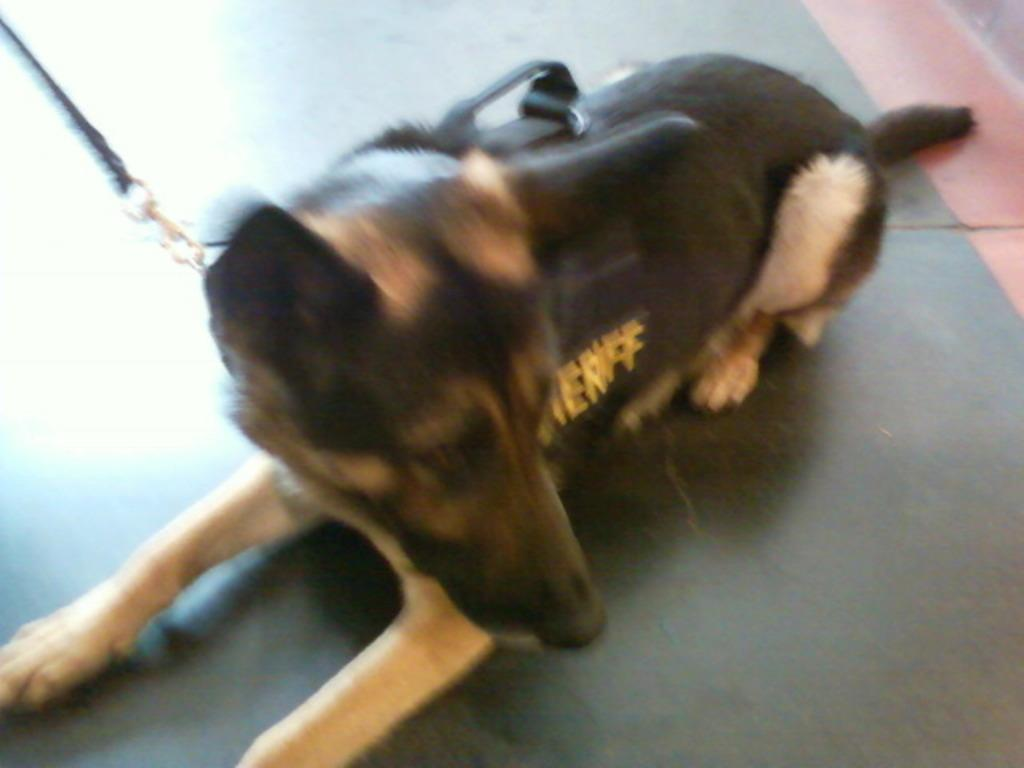What animal can be seen in the image? There is a dog in the image. What position is the dog in? The dog is laid on the floor. What type of bag can be seen on the seashore in the image? There is no bag or seashore present in the image; it only features a dog laid on the floor. 